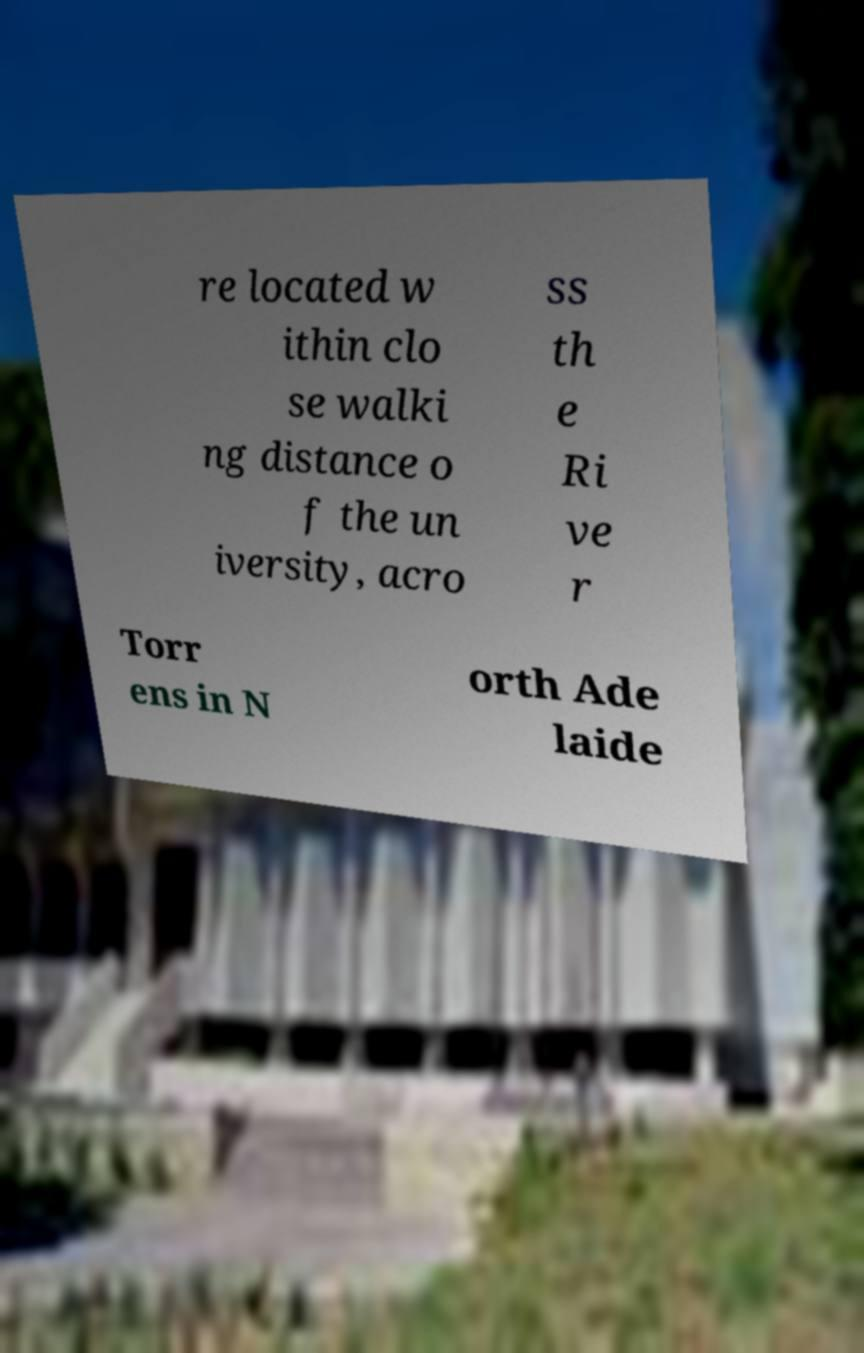Can you read and provide the text displayed in the image?This photo seems to have some interesting text. Can you extract and type it out for me? re located w ithin clo se walki ng distance o f the un iversity, acro ss th e Ri ve r Torr ens in N orth Ade laide 